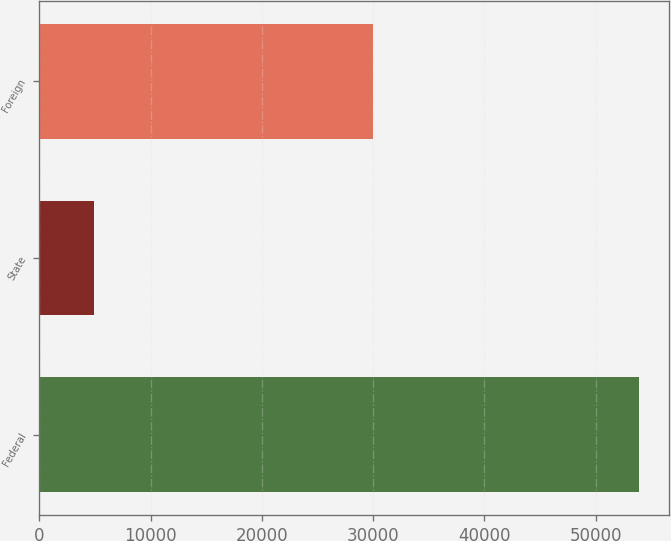Convert chart. <chart><loc_0><loc_0><loc_500><loc_500><bar_chart><fcel>Federal<fcel>State<fcel>Foreign<nl><fcel>53937<fcel>4896<fcel>29942<nl></chart> 